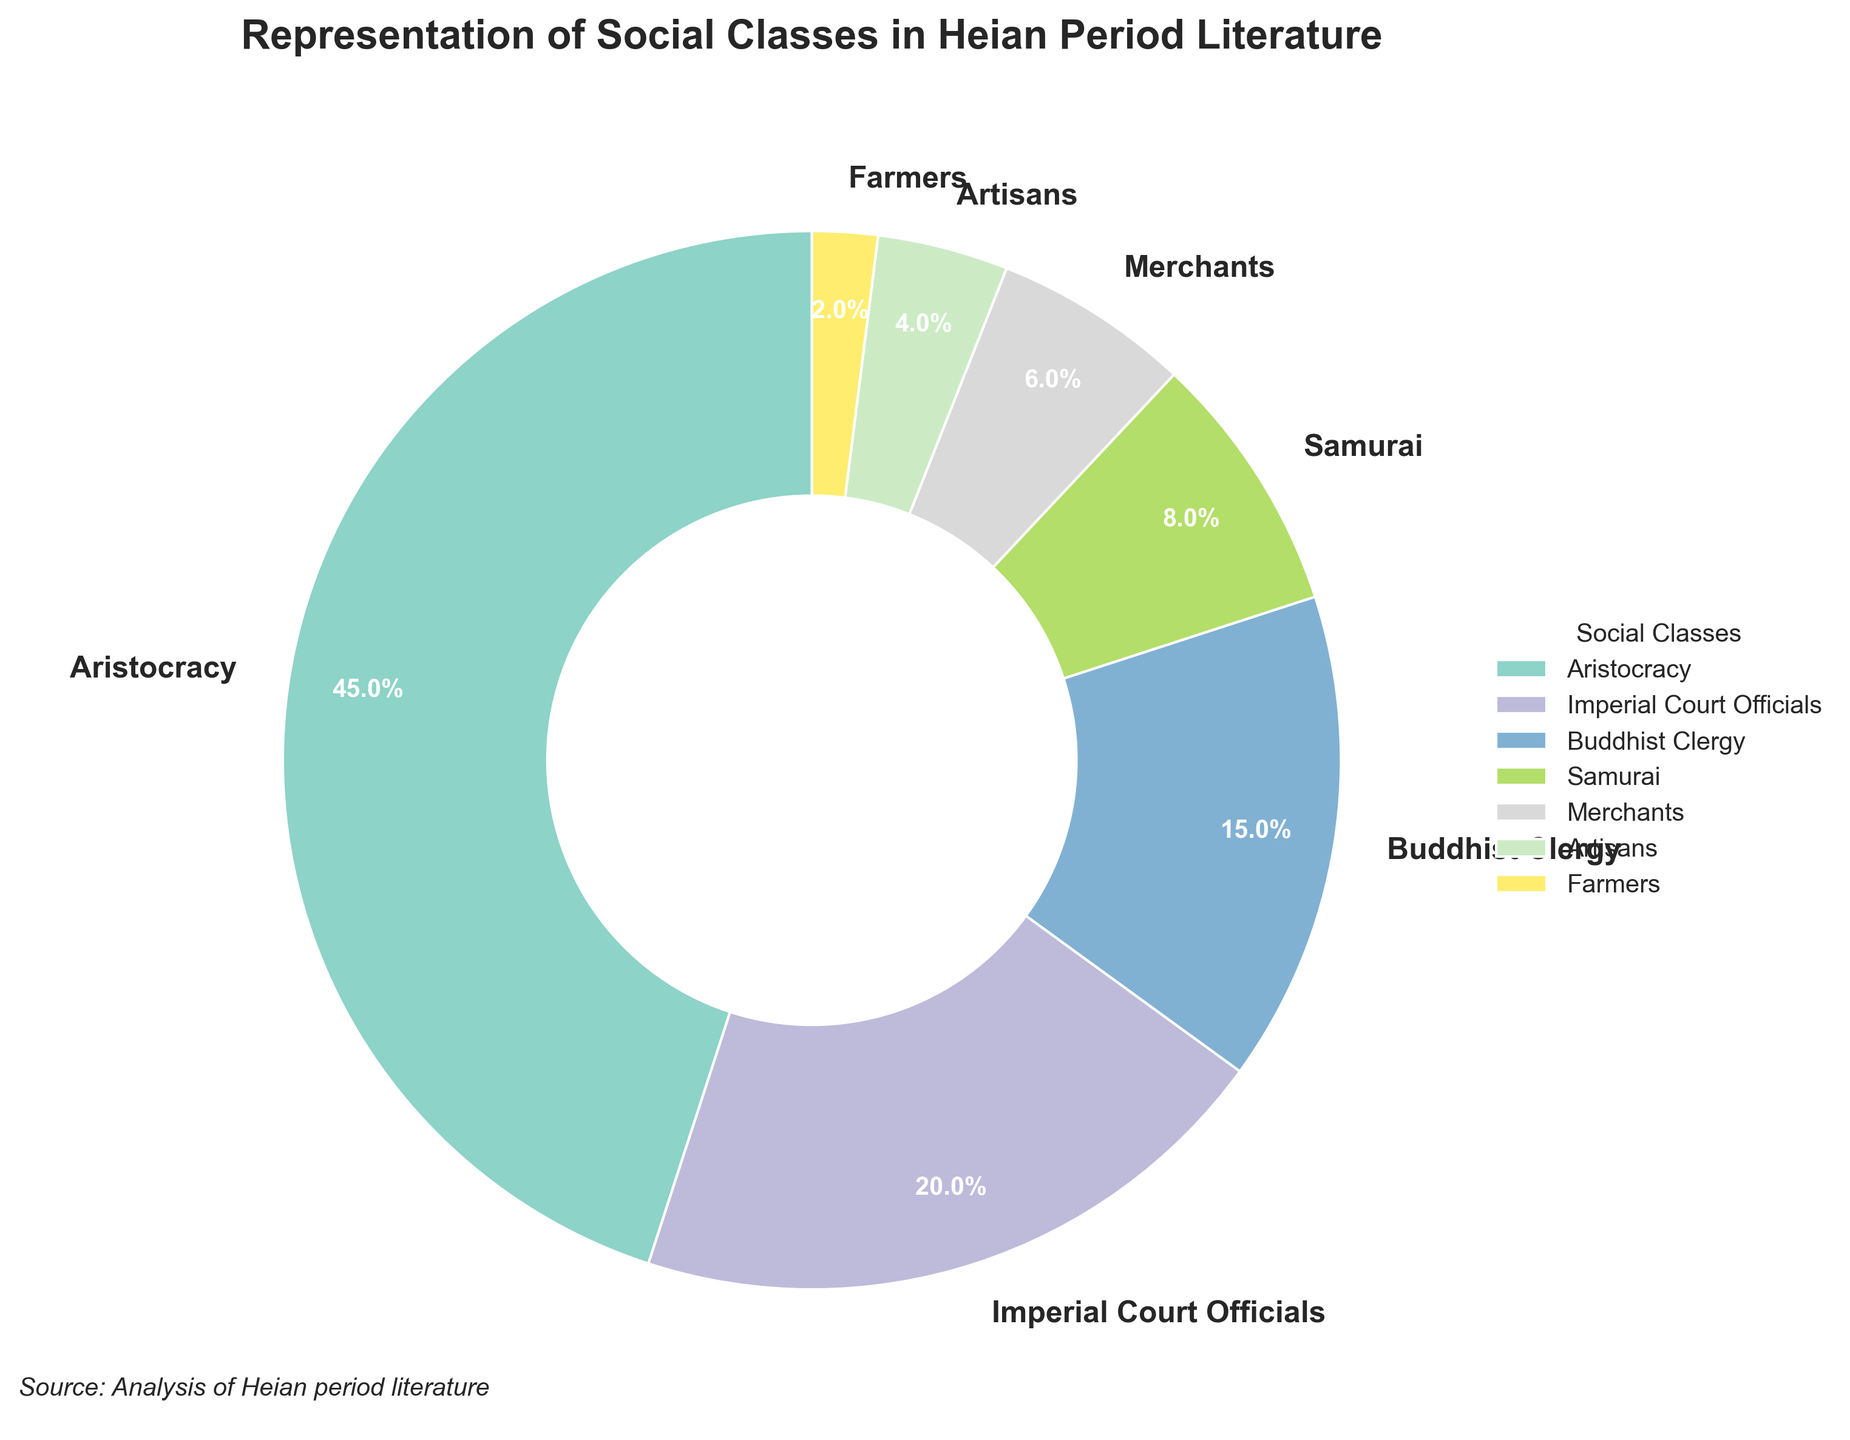What percentage of the chart is occupied by the Aristocracy? Look at the segment labeled "Aristocracy" and find the percentage value next to it.
Answer: 45% Which social class has the smallest representation in Heian period literature? Observe the segments to identify the one with the lowest percentage. The "Farmers" segment is the smallest, with only 2%.
Answer: Farmers Compare the combined representation of the Aristocracy and Samurai to that of the Imperial Court Officials. Which is larger and by how much? Sum the percentages of the Aristocracy (45%) and Samurai (8%) to get 53%. Compare this with the representation of the Imperial Court Officials (20%). Subtract to find the difference: 53% - 20% = 33%.
Answer: Aristocracy and Samurai by 33% What is the combined representation of the Buddhist Clergy and Merchants? Add the percentages of the Buddhist Clergy (15%) and Merchants (6%) to find the total: 15% + 6% = 21%.
Answer: 21% Which social class has a greater representation: Artisans or Samurai? Compare the percentages of Artisans (4%) and Samurai (8%). Samurai has a greater representation.
Answer: Samurai List all the social classes that have a representation of less than 10%. Identify and list the segments with percentages below 10%, which are: Samurai (8%), Merchants (6%), Artisans (4%), and Farmers (2%).
Answer: Samurai, Merchants, Artisans, Farmers What is the difference in representation between the Aristocracy and the Buddhist Clergy? Subtract the percentage of the Buddhist Clergy (15%) from that of the Aristocracy (45%): 45% - 15% = 30%.
Answer: 30% If the Buddhist Clergy and Samurai's representations were combined, what fraction of the total chart would they represent? Add the percentages of the Buddhist Clergy (15%) and Samurai (8%): 15% + 8% = 23%. Since the chart represents the whole (or 100%), the fraction is 23/100.
Answer: 23/100 How does the representation of the Imperial Court Officials compare to the combined representation of Artisans and Farmers? Add the percentages of Artisans (4%) and Farmers (2%): 4% + 2% = 6%. Compare this with the percentage of the Imperial Court Officials (20%). The representation of the Imperial Court Officials is greater.
Answer: Imperial Court Officials greater What fraction of the chart is represented by classes other than the Aristocracy? Subtract the percentage of the Aristocracy (45%) from the total (100%): 100% - 45% = 55%. So, the fraction is 55/100.
Answer: 55/100 